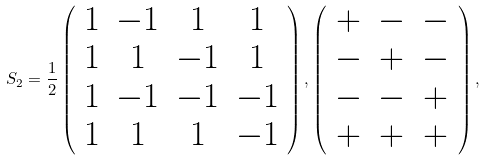Convert formula to latex. <formula><loc_0><loc_0><loc_500><loc_500>S _ { 2 } = \frac { 1 } { 2 } \left ( \begin{array} { c c c c } 1 & - 1 & 1 & 1 \\ 1 & 1 & - 1 & 1 \\ 1 & - 1 & - 1 & - 1 \\ 1 & 1 & 1 & - 1 \\ \end{array} \right ) , \left ( \begin{array} { c c c } + & - & - \\ - & + & - \\ - & - & + \\ + & + & + \\ \end{array} \right ) ,</formula> 